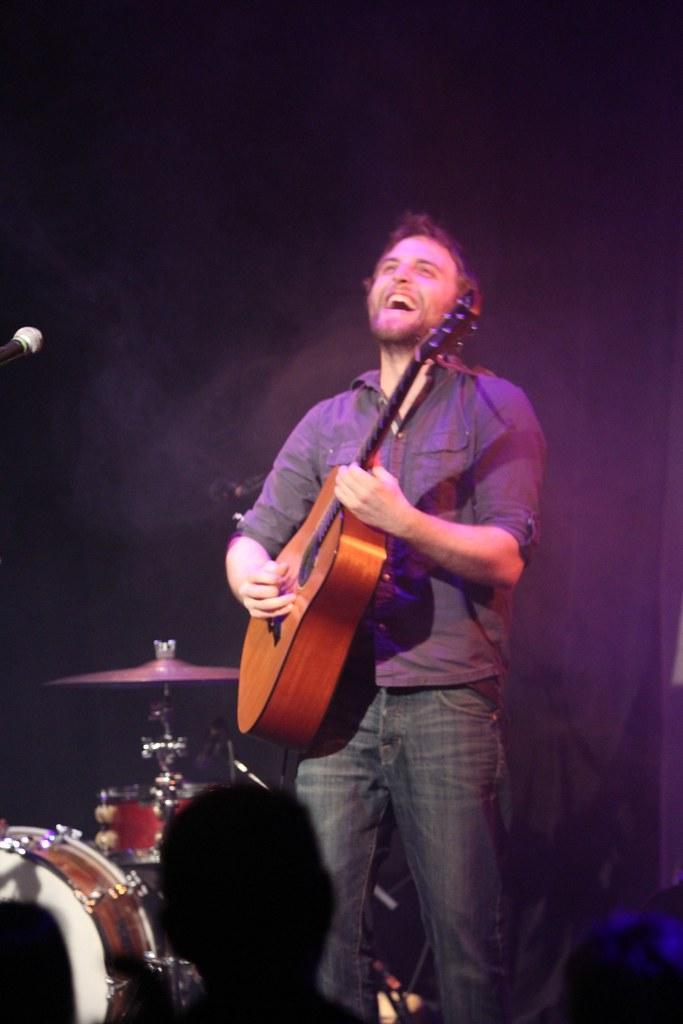How would you summarize this image in a sentence or two? This image is taken during night time on the stage. In this a person standing in a middle and playing a guitar and having a smile on his face. In the left bottom, musical instruments are kept and persons head is visible. 